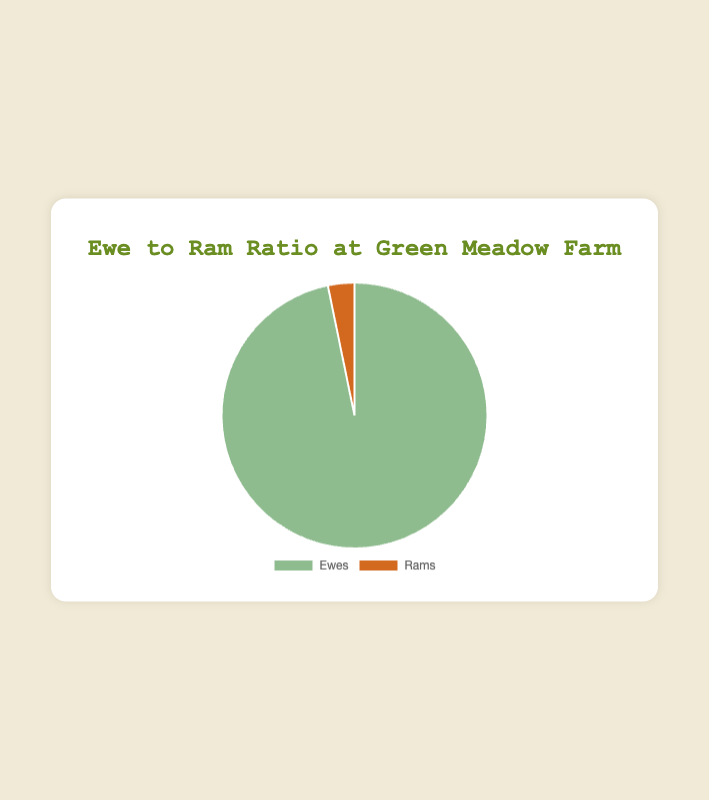what is the number of ewes at Green Meadow Farm? The data shows the number of ewes and rams at Green Meadow Farm, and the chart is generated based on that. Looking at the figure, you can see the total number of ewes.
Answer: 150 How many total sheep are there at Green Meadow Farm? To get the total sheep, sum up the number of ewes and rams at Green Meadow Farm. The chart shows 150 ewes and 5 rams, so you add these together.
Answer: 155 What percentage of the sheep at Green Meadow Farm are rams? Calculate the percentage by taking the number of rams (5) and dividing it by the total number of sheep (155), then multiplying by 100. \[\left( \frac{5}{155} \right) * 100 \approx 3.23\%\]
Answer: 3.23% Which has a larger value, the number of ewes or the number of rams at Green Meadow Farm, and by how much? Compare the number of ewes (150) and rams (5) at Green Meadow Farm. Subtract the number of rams from the number of ewes to find the difference.
Answer: 145 What is the ratio of ewes to rams at Green Meadow Farm in simplest form? To get the ratio in simplest form, divide both numbers by their greatest common divisor (GCD). The number of ewes is 150 and rams is 5, and their GCD is 5. \[\frac{150 \div 5}{5 \div 5} = 30:1\]
Answer: 30:1 What are the colors representing ewes and rams in the pie chart? The chart visually distinguishes between ewes and rams using different colors. From the figure, you can see the colors used to represent each.
Answer: Ewes: green, Rams: brown If Green Meadow Farm decided to increase the number of rams to 10 while keeping ewes the same, what would be the new ratio of ewes to rams? Add the hypothetical increase of rams to the current number of ewes and calculate the new ratio. \[\frac{150}{10} = 15:1\]
Answer: 15:1 Is the proportion of ewes larger than that of the rams at Green Meadow Farm? Visually inspect the size of the segments in the pie chart. The ewes' segment appears significantly larger than the rams' segment, indicating a larger proportion.
Answer: Yes If half of the ewes were sold, what percentage of the remaining sheep would be ewes? If half of the 150 ewes were sold, 75 would remain. Add the remaining ewes to the number of rams (5), making a total of 80 sheep. The percentage of ewes is then \[\left( \frac{75}{80} \right) * 100 \approx 93.75\%\]
Answer: 93.75% If 10 more ewes were added to the farm, what would be the new percentage of ewes? Adding 10 more ewes changes the total number of ewes to 160, and the total number of sheep to 165. Calculate the new percentage of ewes. \[\left( \frac{160}{165} \right) * 100 \approx 96.97\%\]
Answer: 96.97% 